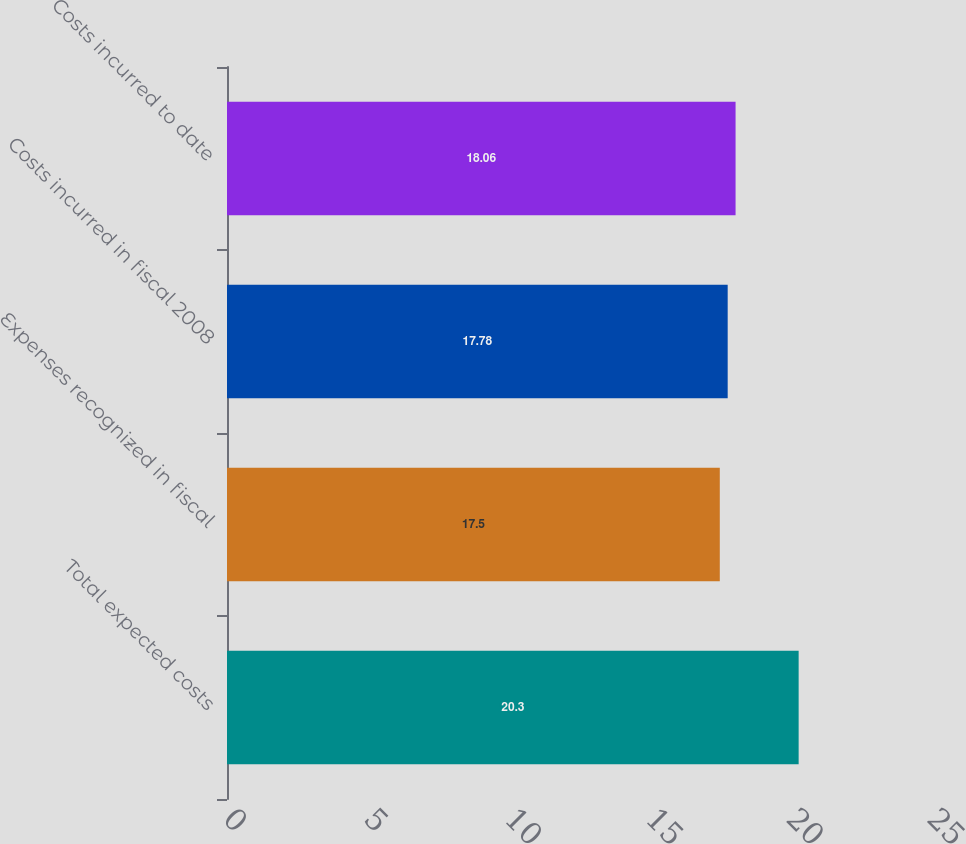<chart> <loc_0><loc_0><loc_500><loc_500><bar_chart><fcel>Total expected costs<fcel>Expenses recognized in fiscal<fcel>Costs incurred in fiscal 2008<fcel>Costs incurred to date<nl><fcel>20.3<fcel>17.5<fcel>17.78<fcel>18.06<nl></chart> 